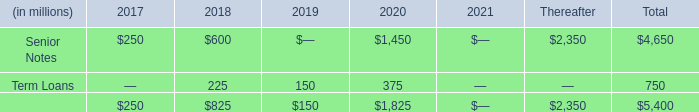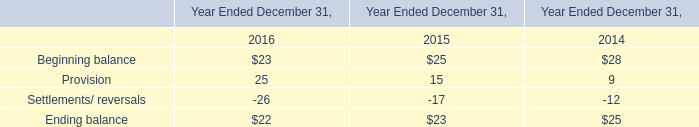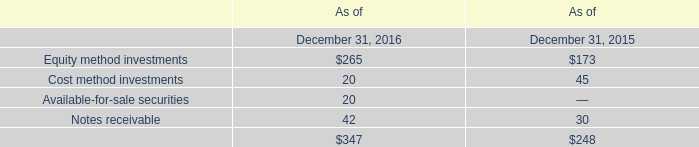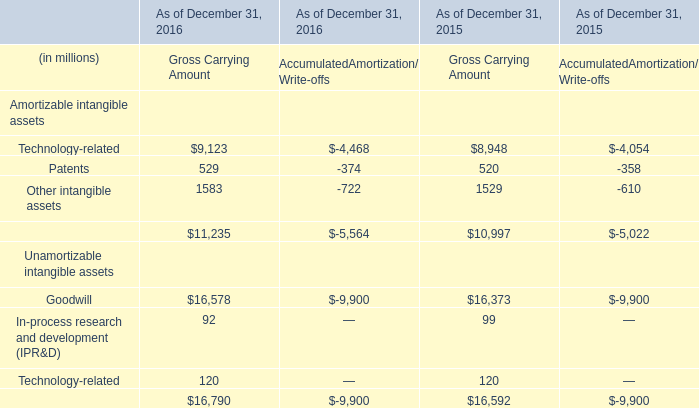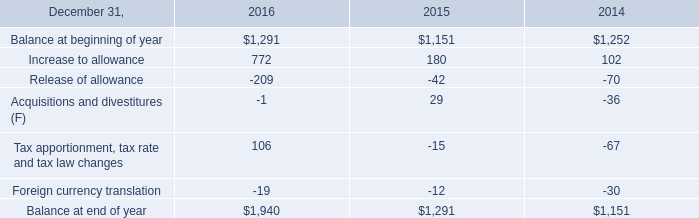what was the increase in the balance at end of the year from 2015 to 2016? 
Computations: ((1940 / 1291) - 1)
Answer: 0.50271. 